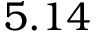Convert formula to latex. <formula><loc_0><loc_0><loc_500><loc_500>5 . 1 4</formula> 